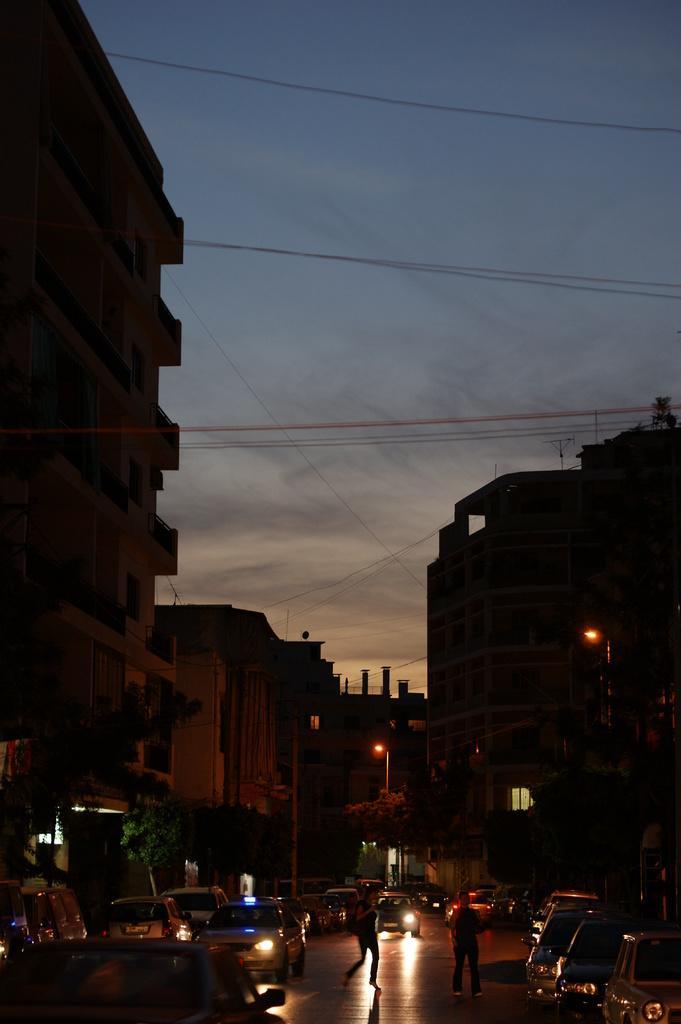In one or two sentences, can you explain what this image depicts? This picture is clicked outside. In the foreground we can see the group of the people and we can see the vehicles running on the road and group of vehicles parked on the ground and we can see the trees, buildings, lampposts and some other items. In the background we can see the sky and the cables and we can see the buildings. 